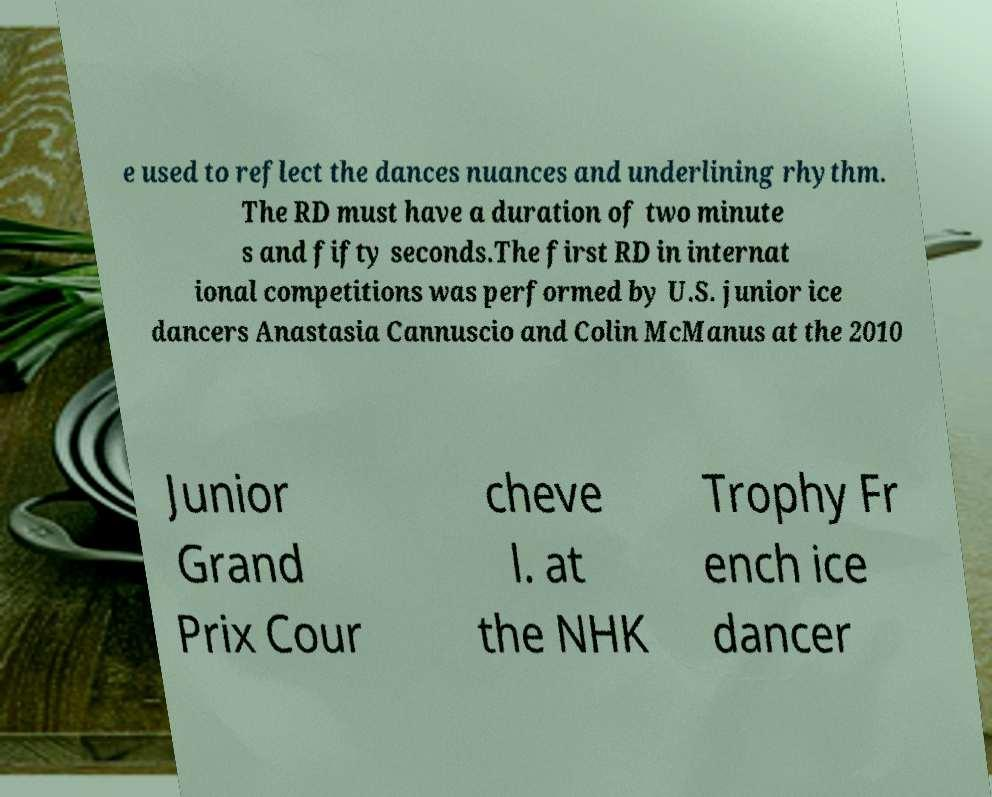What messages or text are displayed in this image? I need them in a readable, typed format. e used to reflect the dances nuances and underlining rhythm. The RD must have a duration of two minute s and fifty seconds.The first RD in internat ional competitions was performed by U.S. junior ice dancers Anastasia Cannuscio and Colin McManus at the 2010 Junior Grand Prix Cour cheve l. at the NHK Trophy Fr ench ice dancer 